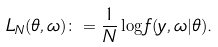Convert formula to latex. <formula><loc_0><loc_0><loc_500><loc_500>L _ { N } ( \theta , \omega ) & \colon = \frac { 1 } { N } \log f ( y , \omega | \theta ) .</formula> 